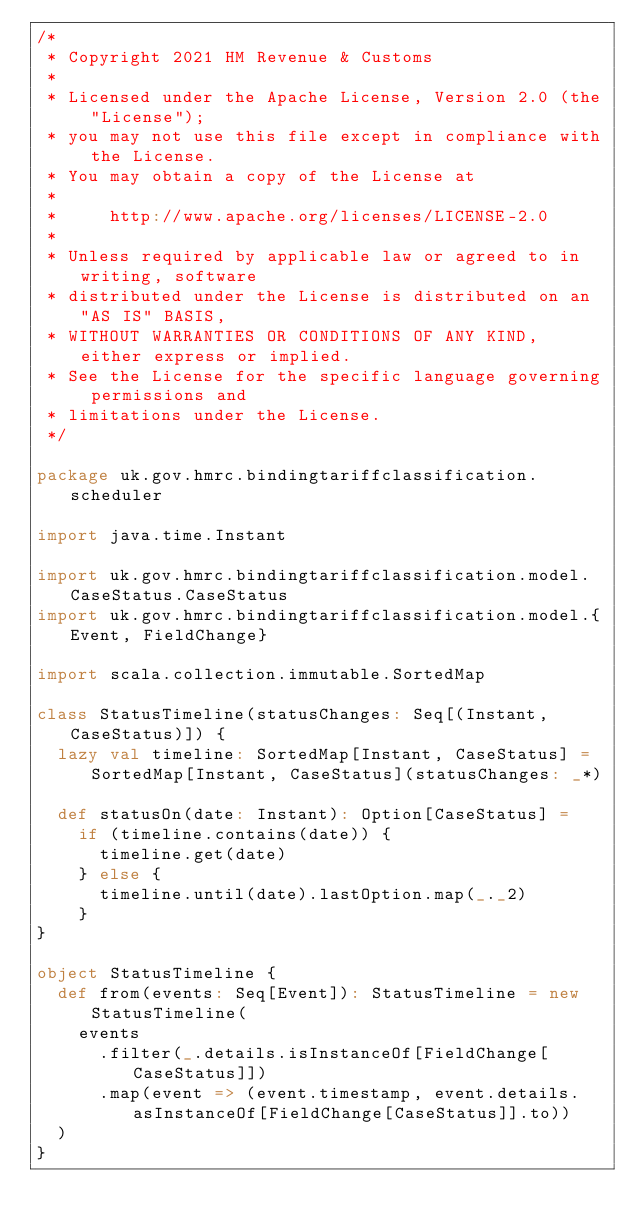<code> <loc_0><loc_0><loc_500><loc_500><_Scala_>/*
 * Copyright 2021 HM Revenue & Customs
 *
 * Licensed under the Apache License, Version 2.0 (the "License");
 * you may not use this file except in compliance with the License.
 * You may obtain a copy of the License at
 *
 *     http://www.apache.org/licenses/LICENSE-2.0
 *
 * Unless required by applicable law or agreed to in writing, software
 * distributed under the License is distributed on an "AS IS" BASIS,
 * WITHOUT WARRANTIES OR CONDITIONS OF ANY KIND, either express or implied.
 * See the License for the specific language governing permissions and
 * limitations under the License.
 */

package uk.gov.hmrc.bindingtariffclassification.scheduler

import java.time.Instant

import uk.gov.hmrc.bindingtariffclassification.model.CaseStatus.CaseStatus
import uk.gov.hmrc.bindingtariffclassification.model.{Event, FieldChange}

import scala.collection.immutable.SortedMap

class StatusTimeline(statusChanges: Seq[(Instant, CaseStatus)]) {
  lazy val timeline: SortedMap[Instant, CaseStatus] = SortedMap[Instant, CaseStatus](statusChanges: _*)

  def statusOn(date: Instant): Option[CaseStatus] =
    if (timeline.contains(date)) {
      timeline.get(date)
    } else {
      timeline.until(date).lastOption.map(_._2)
    }
}

object StatusTimeline {
  def from(events: Seq[Event]): StatusTimeline = new StatusTimeline(
    events
      .filter(_.details.isInstanceOf[FieldChange[CaseStatus]])
      .map(event => (event.timestamp, event.details.asInstanceOf[FieldChange[CaseStatus]].to))
  )
}
</code> 